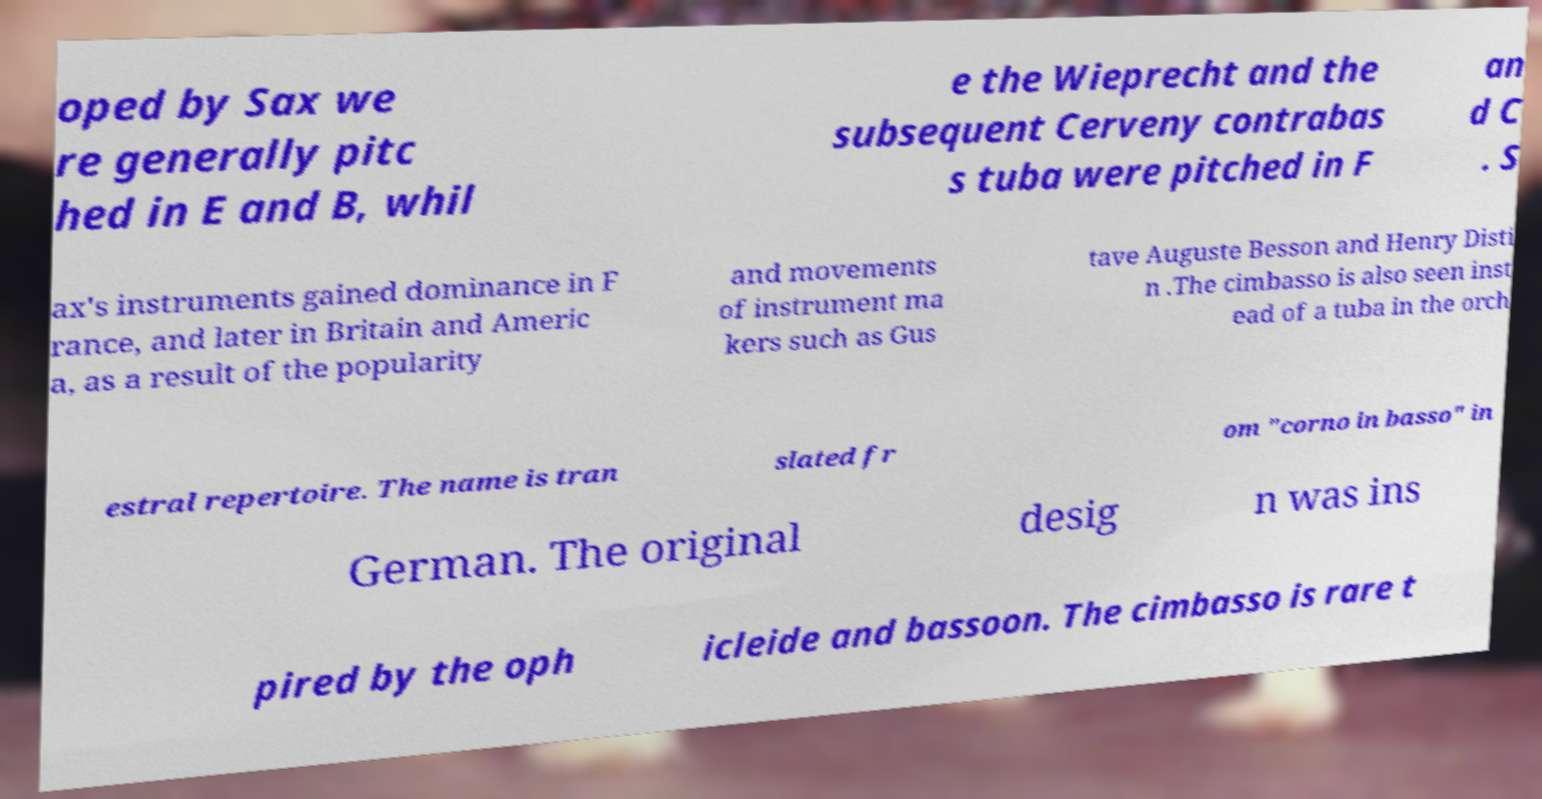Can you accurately transcribe the text from the provided image for me? oped by Sax we re generally pitc hed in E and B, whil e the Wieprecht and the subsequent Cerveny contrabas s tuba were pitched in F an d C . S ax's instruments gained dominance in F rance, and later in Britain and Americ a, as a result of the popularity and movements of instrument ma kers such as Gus tave Auguste Besson and Henry Disti n .The cimbasso is also seen inst ead of a tuba in the orch estral repertoire. The name is tran slated fr om "corno in basso" in German. The original desig n was ins pired by the oph icleide and bassoon. The cimbasso is rare t 